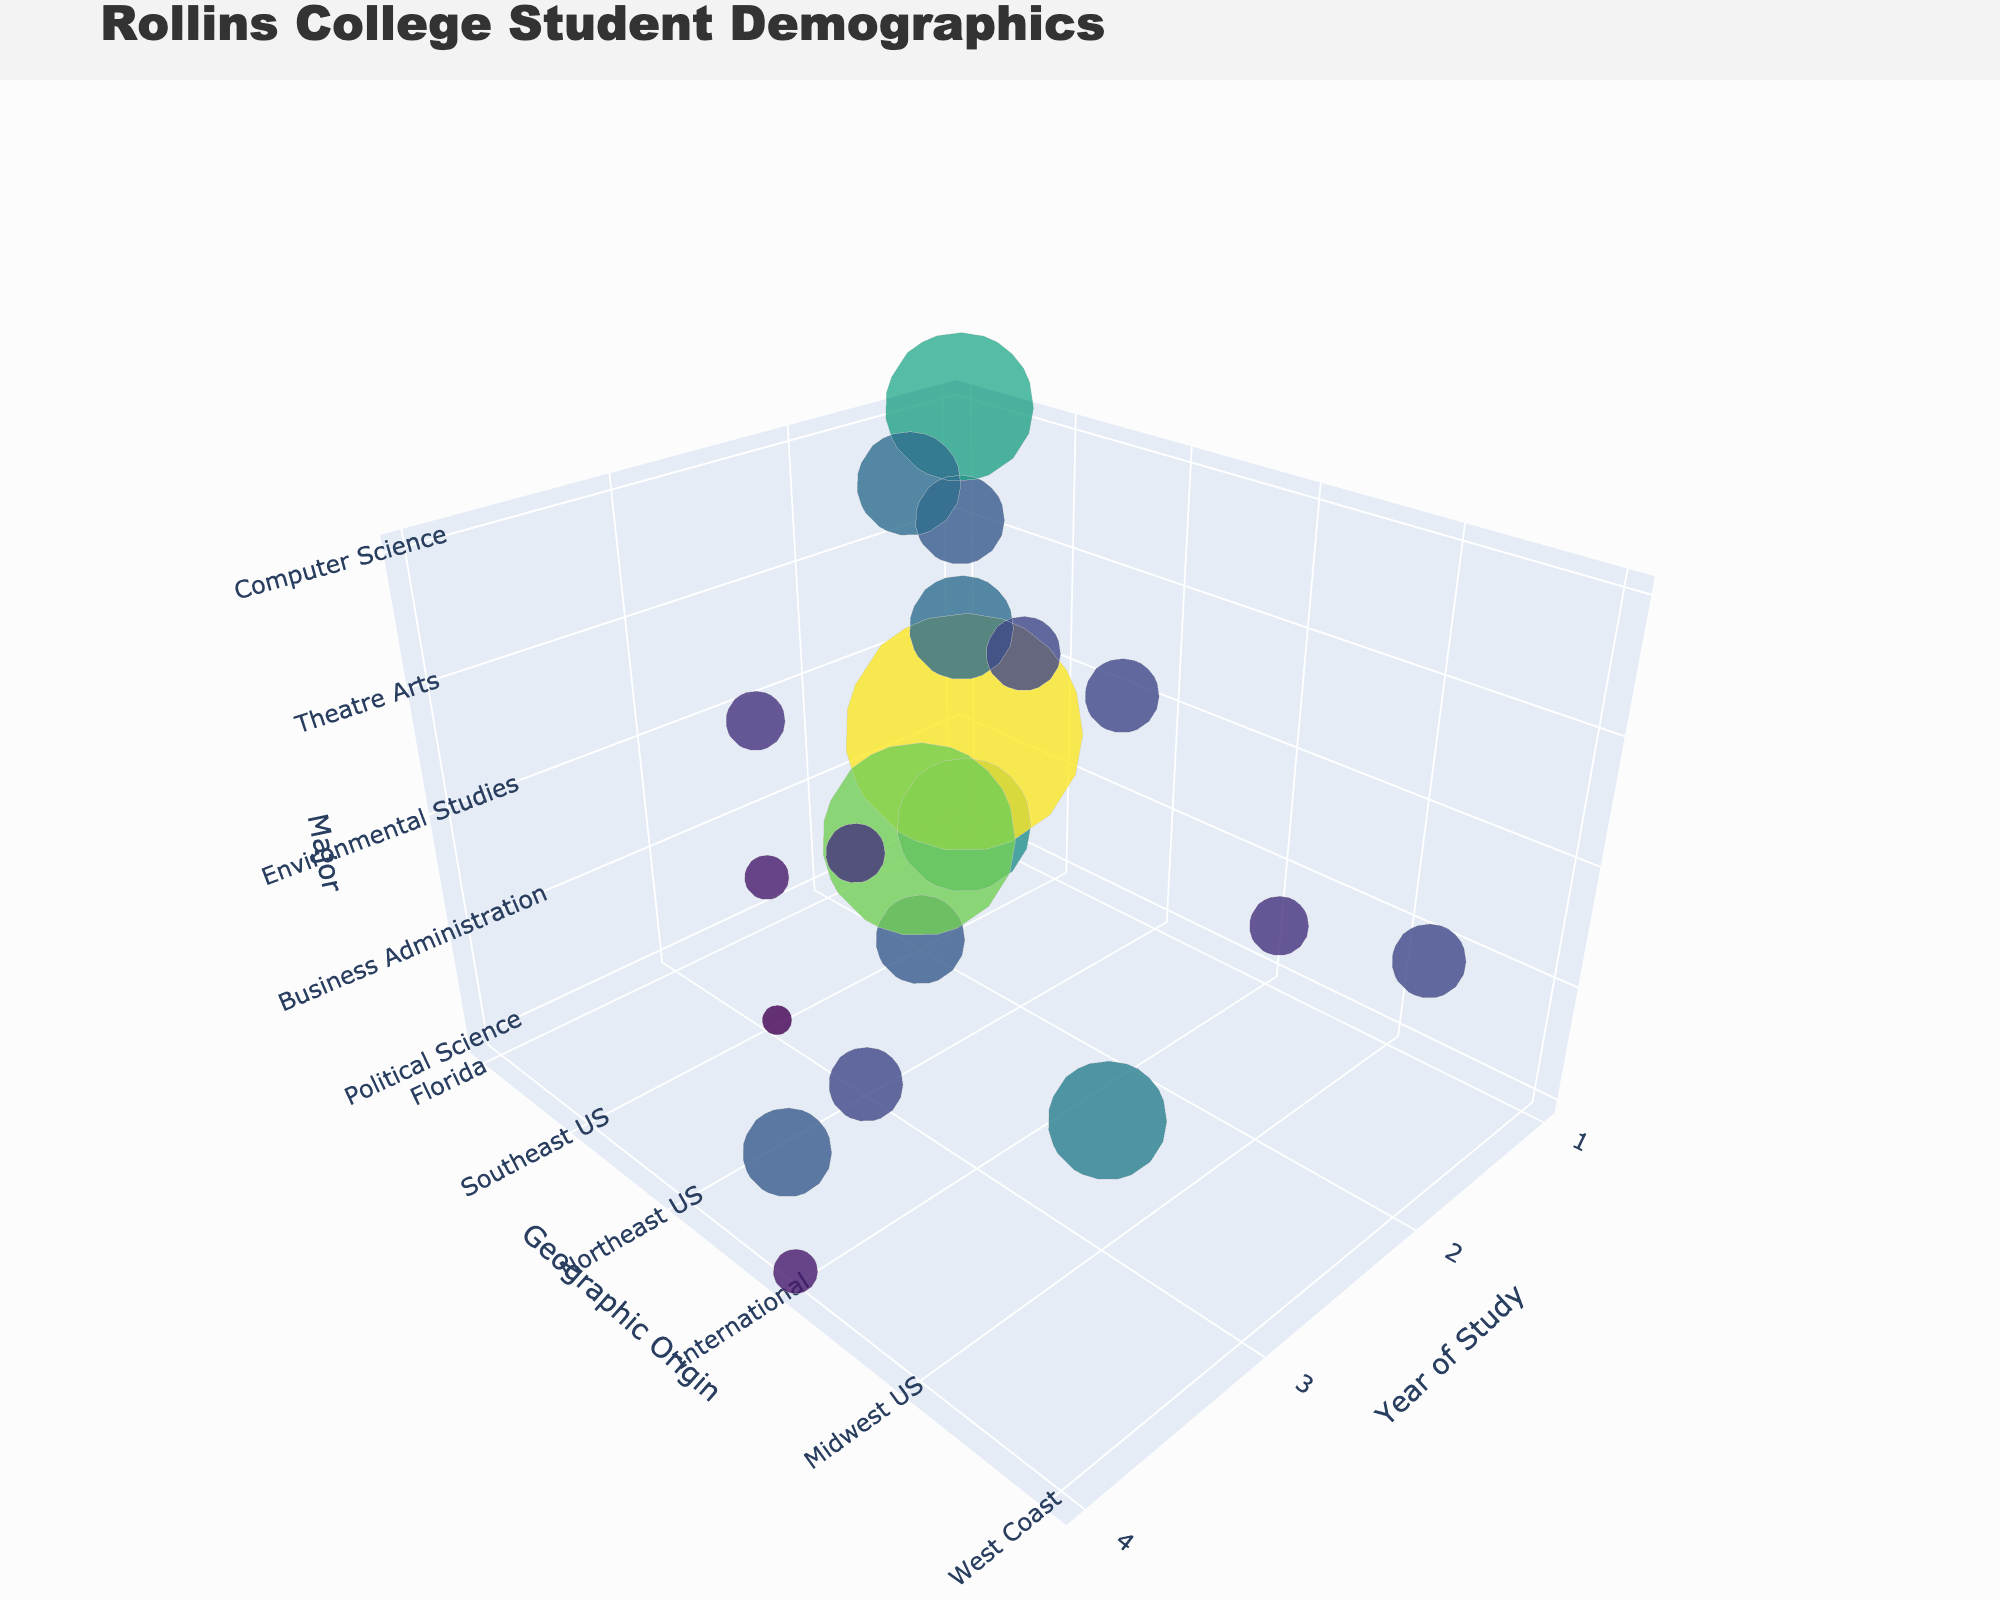How many students are in their first year of Political Science? Look for the bubble representing first-year students in Political Science. The text annotation gives the number of students.
Answer: 45 Which major has the highest number of students in the second year from the Southeast US? Compare the sizes of the bubbles for second-year students from the Southeast US across all majors. The Business Administration bubble is the largest.
Answer: Business Administration What is the sum of students in the fourth year for the International origin? Add the number of students from the fourth-year bubbles labeled "International" across all majors: 15 (Political Science) + 30 (Business Administration) + 10 (Environmental Studies) + 15 (Theatre Arts) + 20 (Computer Science).
Answer: 90 How does the number of Theatre Arts students from Northeast US in the second year compare to those in the fourth year? Check the sizes of the bubbles for second and fourth-year students from the Northeast US in Theatre Arts. The second-year bubble is larger at 25 students compared to the fourth year's 15 students.
Answer: Larger Which major has the smallest bubble for third-year students from the Midwest US? Among third-year students from the Midwest US, identify the smallest bubble by comparing their sizes. The Political Science bubble is the smallest.
Answer: Political Science What is the average number of first-year students across all majors from Florida? Find the bubbles for first-year students from Florida, sum their counts, and divide by the number of majors: (45 + 80 + 35 + 30 + 50)/5.
Answer: 48 What is the size of the bubble representing Environmental Studies students from the West Coast in the second year? Identify the bubble for Environmental Studies in the second year from the West Coast and note the student count.
Answer: 25 Compare the number of Computer Science students in their third year from the Midwest US to the number of Business Administration students from the same group. Look at the bubble sizes for third-year Midwest US students in both Computer Science and Business Administration. There are 25 students in Computer Science and 40 in Business Administration.
Answer: Fewer Is the number of first-year students in Business Administration from Florida greater than the total Environmental Studies students from all origins? Sum the student counts for Environmental Studies from all origins and compare it to the first-year Business Administration students from Florida. (35 + 25 + 20 + 10) = 90, which is higher than 80.
Answer: No 